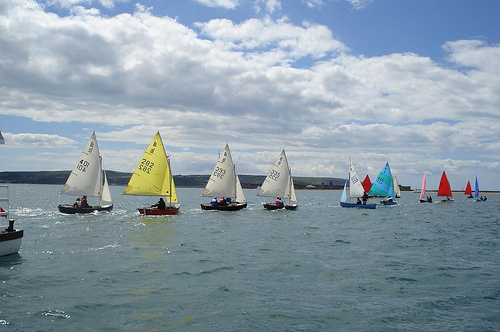<image>
Is the sail boat on the sea? Yes. Looking at the image, I can see the sail boat is positioned on top of the sea, with the sea providing support. 